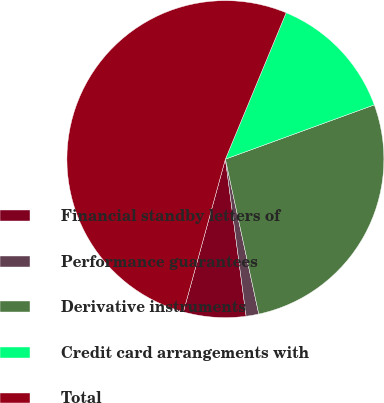<chart> <loc_0><loc_0><loc_500><loc_500><pie_chart><fcel>Financial standby letters of<fcel>Performance guarantees<fcel>Derivative instruments<fcel>Credit card arrangements with<fcel>Total<nl><fcel>6.36%<fcel>1.29%<fcel>27.19%<fcel>13.18%<fcel>52.0%<nl></chart> 